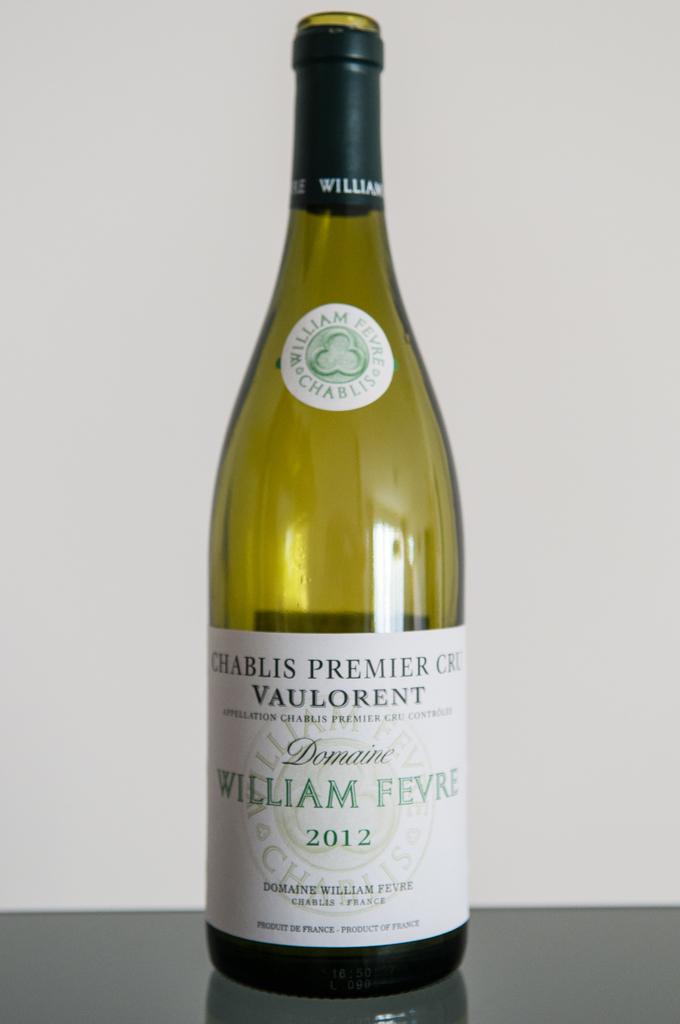What name is in green on the bottle?
Provide a short and direct response. William fevre. 